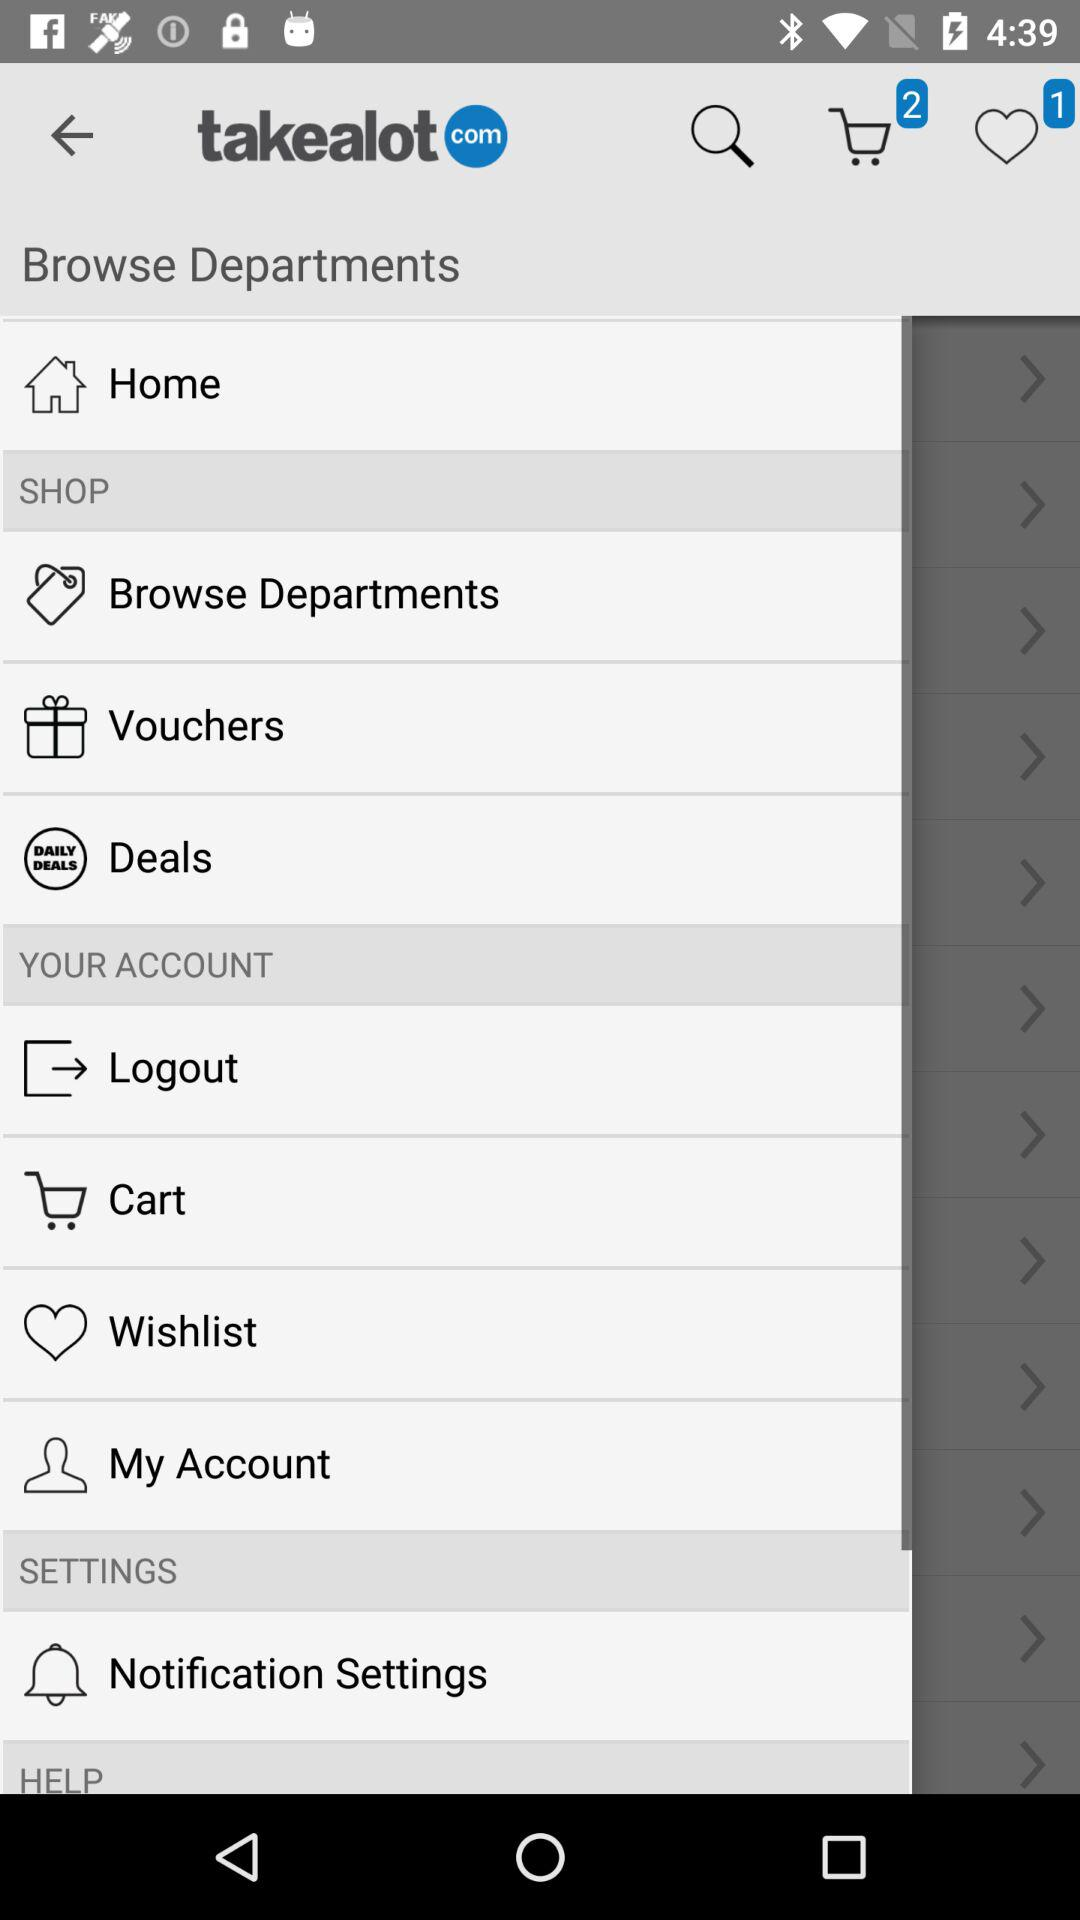What is the application name? The application name is "Takealot – Online Shopping App". 